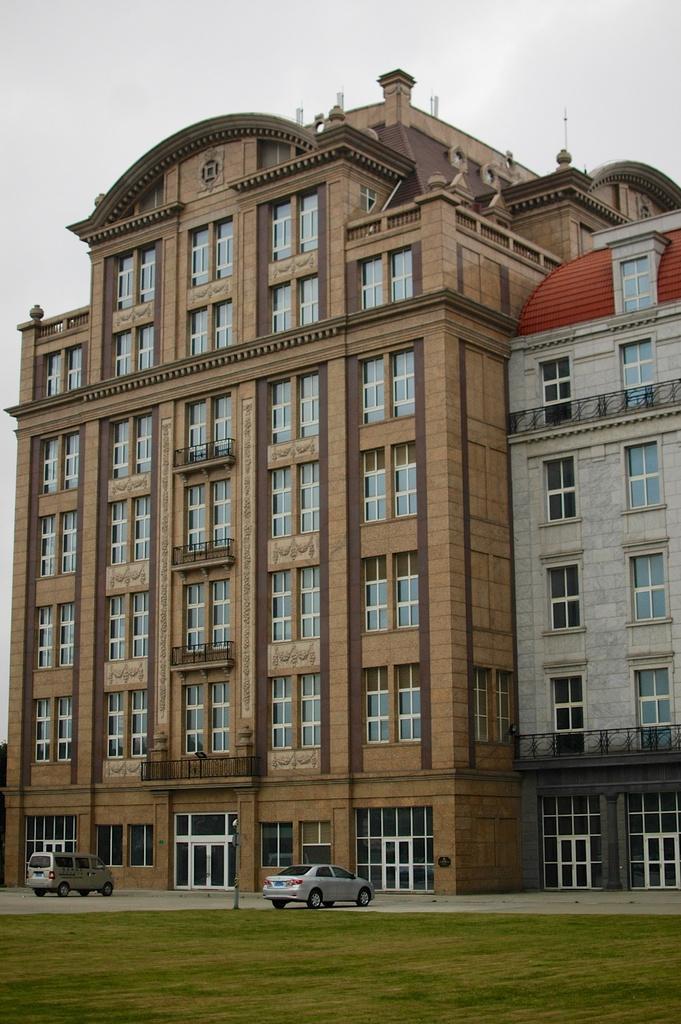How would you summarize this image in a sentence or two? In the image there is a building in the back with many windows and cars in front of it on the road and above its sky. 